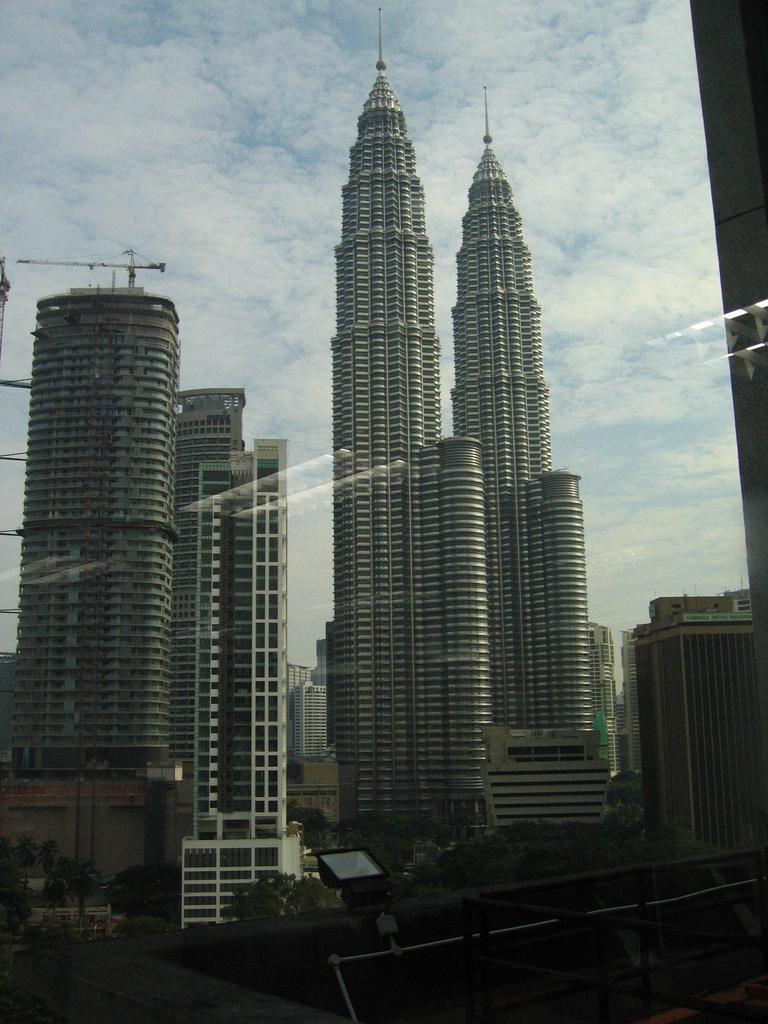Can you describe this image briefly? In this image, we can see some buildings. There is a light on the wall which is at the bottom of the image. There are clouds in the sky. 